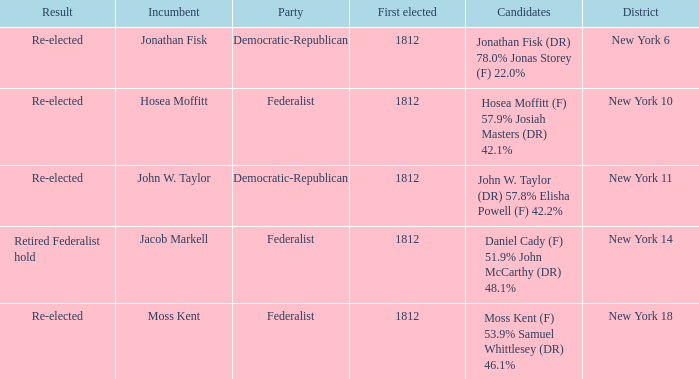Name the most first elected 1812.0. 